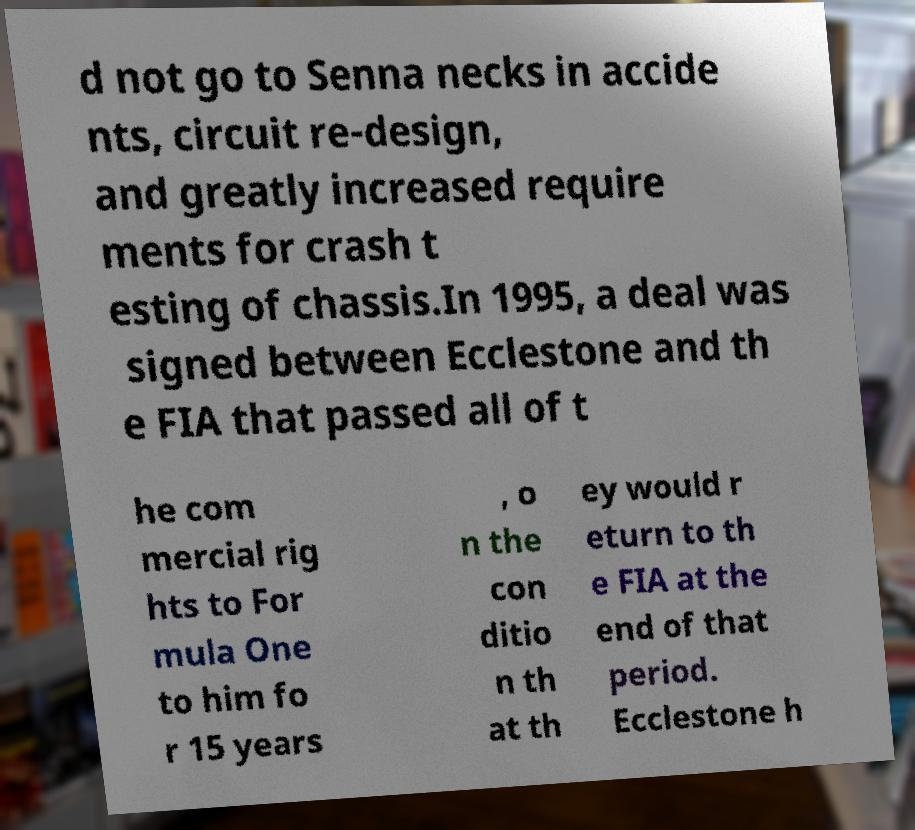Could you extract and type out the text from this image? d not go to Senna necks in accide nts, circuit re-design, and greatly increased require ments for crash t esting of chassis.In 1995, a deal was signed between Ecclestone and th e FIA that passed all of t he com mercial rig hts to For mula One to him fo r 15 years , o n the con ditio n th at th ey would r eturn to th e FIA at the end of that period. Ecclestone h 